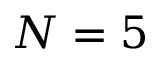<formula> <loc_0><loc_0><loc_500><loc_500>N = 5</formula> 